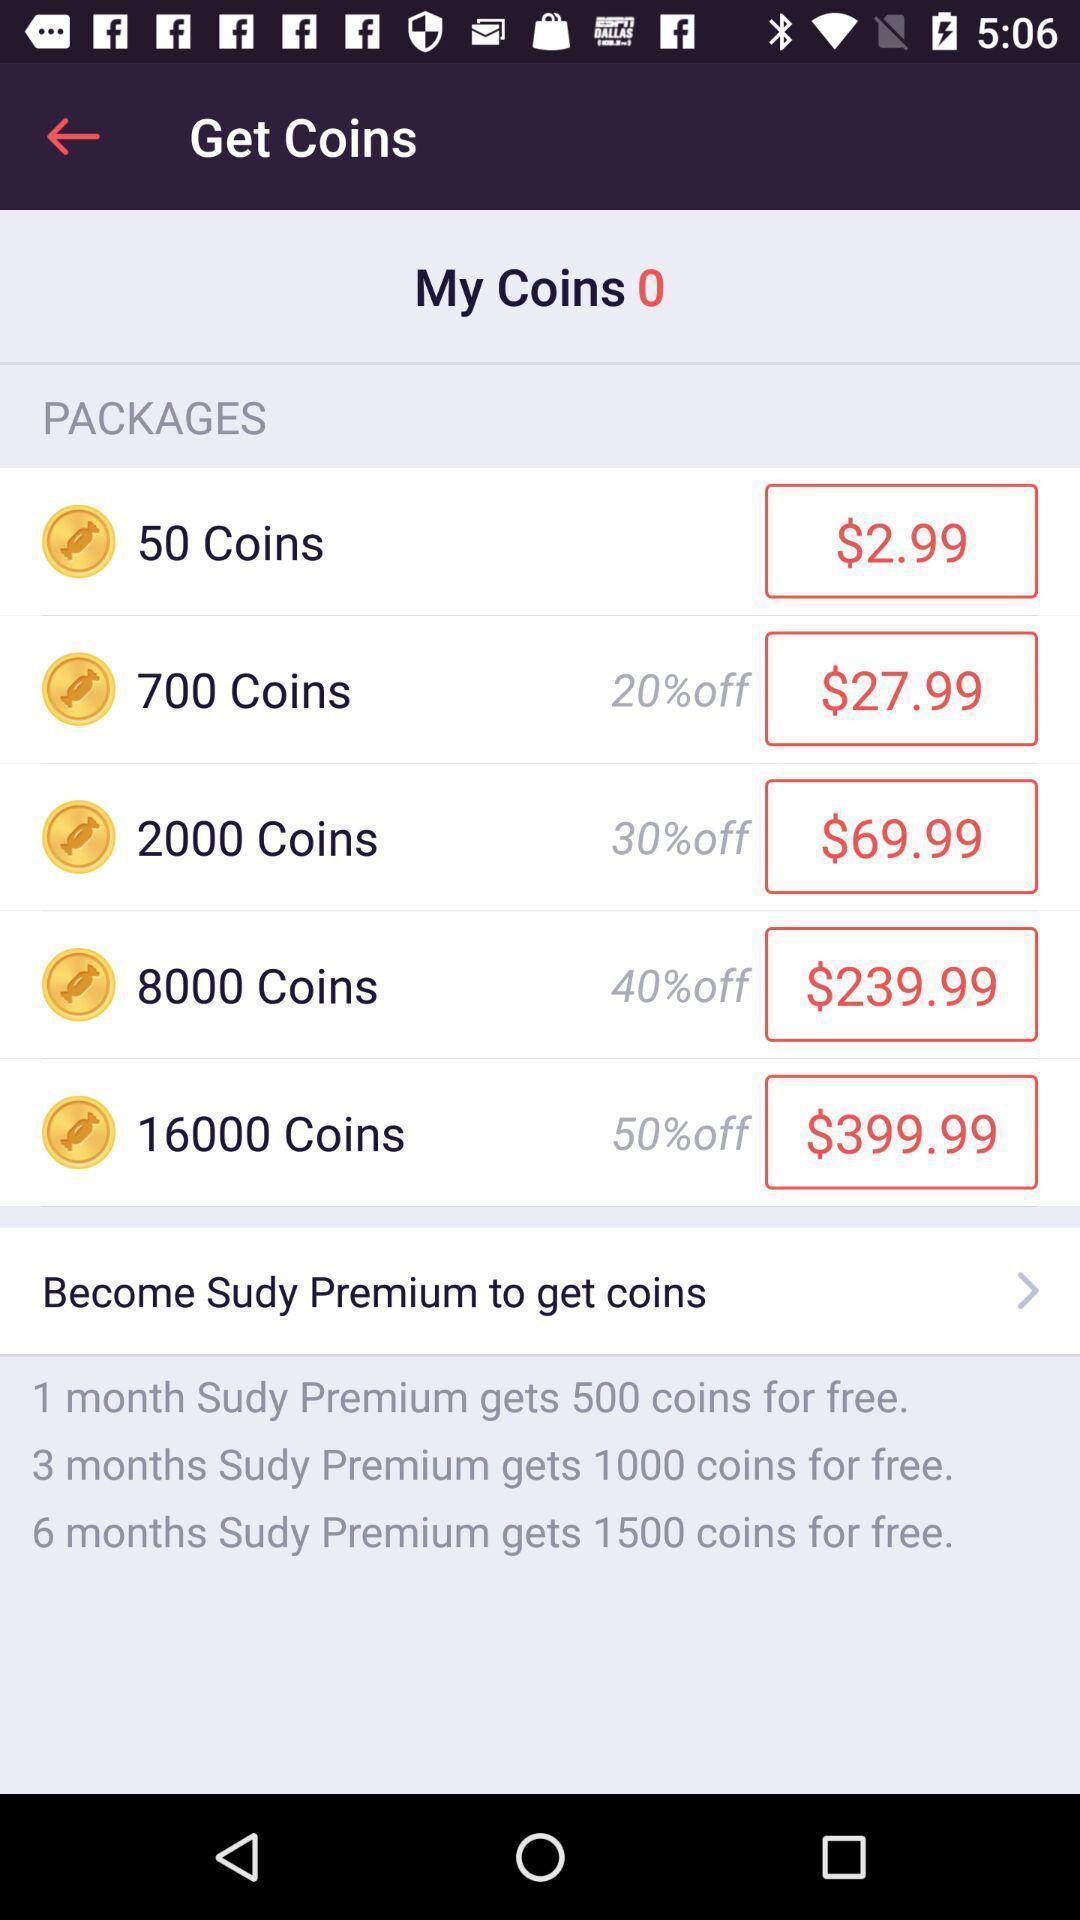Explain the elements present in this screenshot. Screen showing packages for coins. 